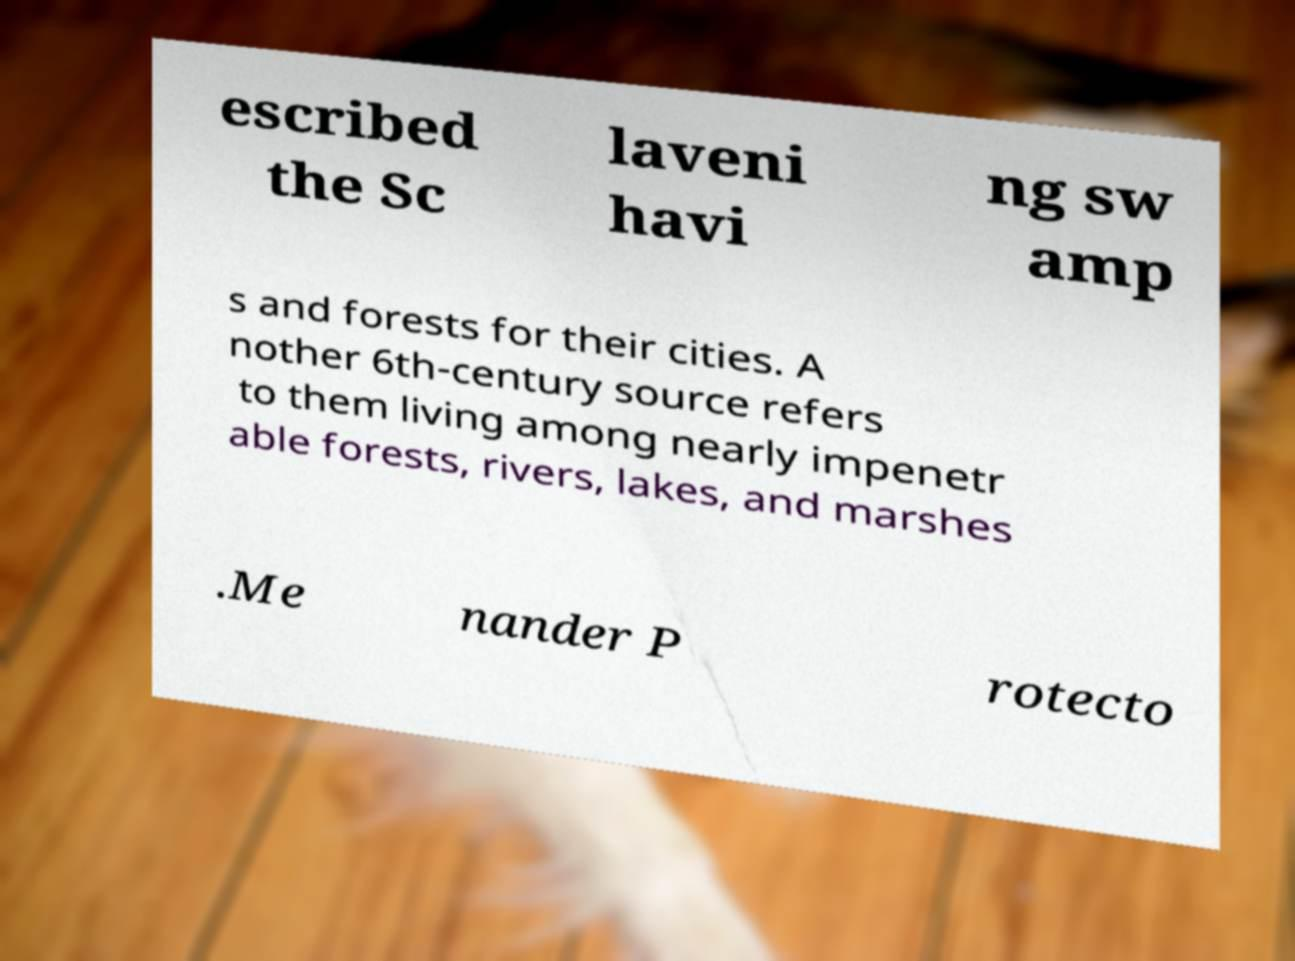Can you accurately transcribe the text from the provided image for me? escribed the Sc laveni havi ng sw amp s and forests for their cities. A nother 6th-century source refers to them living among nearly impenetr able forests, rivers, lakes, and marshes .Me nander P rotecto 